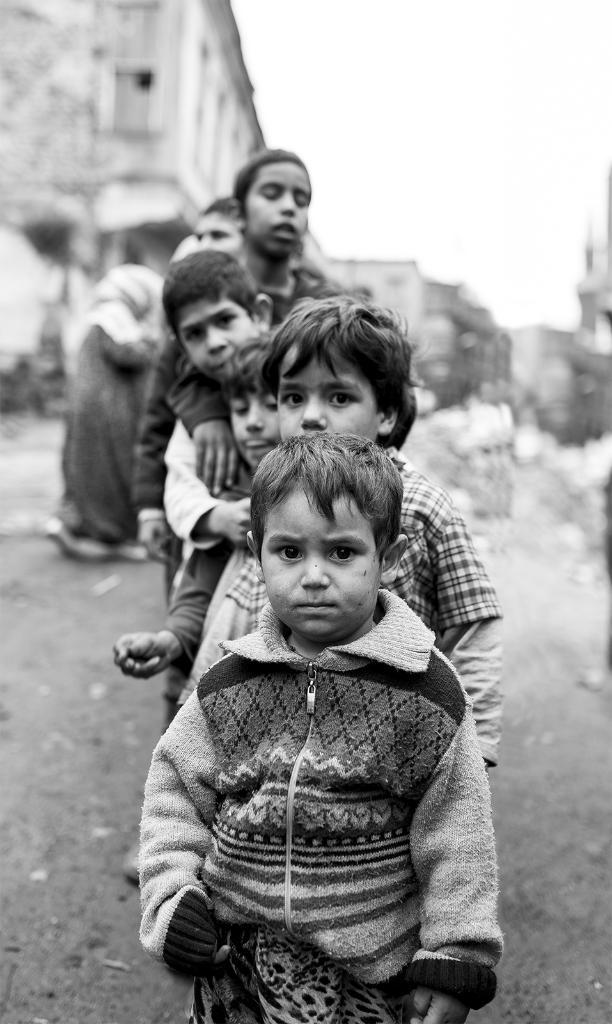Who or what is present in the image? There are people in the image. What can be seen in the distance behind the people? There are buildings in the background of the image. How is the image presented in terms of color? The image is in black and white. What type of quill is being used by the people in the image? There is no quill present in the image; it is in black and white and features people and buildings. 